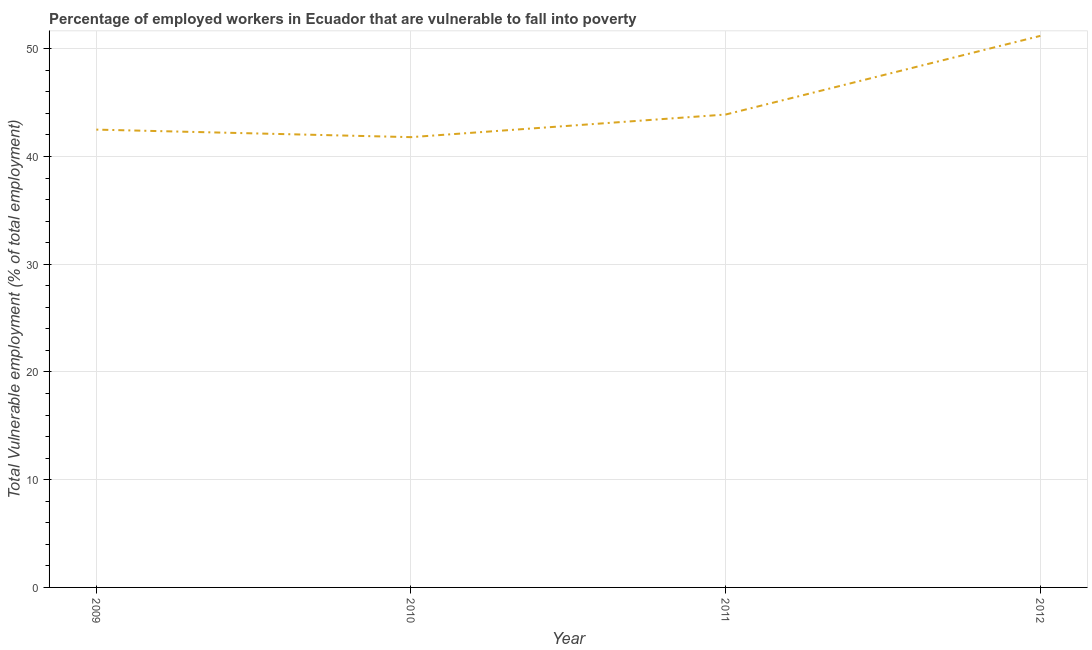What is the total vulnerable employment in 2011?
Provide a short and direct response. 43.9. Across all years, what is the maximum total vulnerable employment?
Your answer should be compact. 51.2. Across all years, what is the minimum total vulnerable employment?
Your answer should be compact. 41.8. In which year was the total vulnerable employment maximum?
Your response must be concise. 2012. In which year was the total vulnerable employment minimum?
Ensure brevity in your answer.  2010. What is the sum of the total vulnerable employment?
Your answer should be compact. 179.4. What is the difference between the total vulnerable employment in 2009 and 2012?
Offer a terse response. -8.7. What is the average total vulnerable employment per year?
Offer a terse response. 44.85. What is the median total vulnerable employment?
Provide a succinct answer. 43.2. What is the ratio of the total vulnerable employment in 2009 to that in 2011?
Keep it short and to the point. 0.97. Is the total vulnerable employment in 2009 less than that in 2010?
Your response must be concise. No. What is the difference between the highest and the second highest total vulnerable employment?
Ensure brevity in your answer.  7.3. Is the sum of the total vulnerable employment in 2010 and 2012 greater than the maximum total vulnerable employment across all years?
Your response must be concise. Yes. What is the difference between the highest and the lowest total vulnerable employment?
Ensure brevity in your answer.  9.4. How many lines are there?
Keep it short and to the point. 1. Are the values on the major ticks of Y-axis written in scientific E-notation?
Provide a short and direct response. No. Does the graph contain any zero values?
Your response must be concise. No. Does the graph contain grids?
Your answer should be very brief. Yes. What is the title of the graph?
Give a very brief answer. Percentage of employed workers in Ecuador that are vulnerable to fall into poverty. What is the label or title of the Y-axis?
Your answer should be very brief. Total Vulnerable employment (% of total employment). What is the Total Vulnerable employment (% of total employment) of 2009?
Keep it short and to the point. 42.5. What is the Total Vulnerable employment (% of total employment) in 2010?
Offer a very short reply. 41.8. What is the Total Vulnerable employment (% of total employment) in 2011?
Ensure brevity in your answer.  43.9. What is the Total Vulnerable employment (% of total employment) in 2012?
Offer a very short reply. 51.2. What is the difference between the Total Vulnerable employment (% of total employment) in 2009 and 2010?
Your answer should be compact. 0.7. What is the difference between the Total Vulnerable employment (% of total employment) in 2009 and 2011?
Keep it short and to the point. -1.4. What is the difference between the Total Vulnerable employment (% of total employment) in 2010 and 2011?
Offer a very short reply. -2.1. What is the difference between the Total Vulnerable employment (% of total employment) in 2011 and 2012?
Offer a terse response. -7.3. What is the ratio of the Total Vulnerable employment (% of total employment) in 2009 to that in 2011?
Your answer should be compact. 0.97. What is the ratio of the Total Vulnerable employment (% of total employment) in 2009 to that in 2012?
Offer a very short reply. 0.83. What is the ratio of the Total Vulnerable employment (% of total employment) in 2010 to that in 2011?
Offer a terse response. 0.95. What is the ratio of the Total Vulnerable employment (% of total employment) in 2010 to that in 2012?
Provide a short and direct response. 0.82. What is the ratio of the Total Vulnerable employment (% of total employment) in 2011 to that in 2012?
Your answer should be very brief. 0.86. 